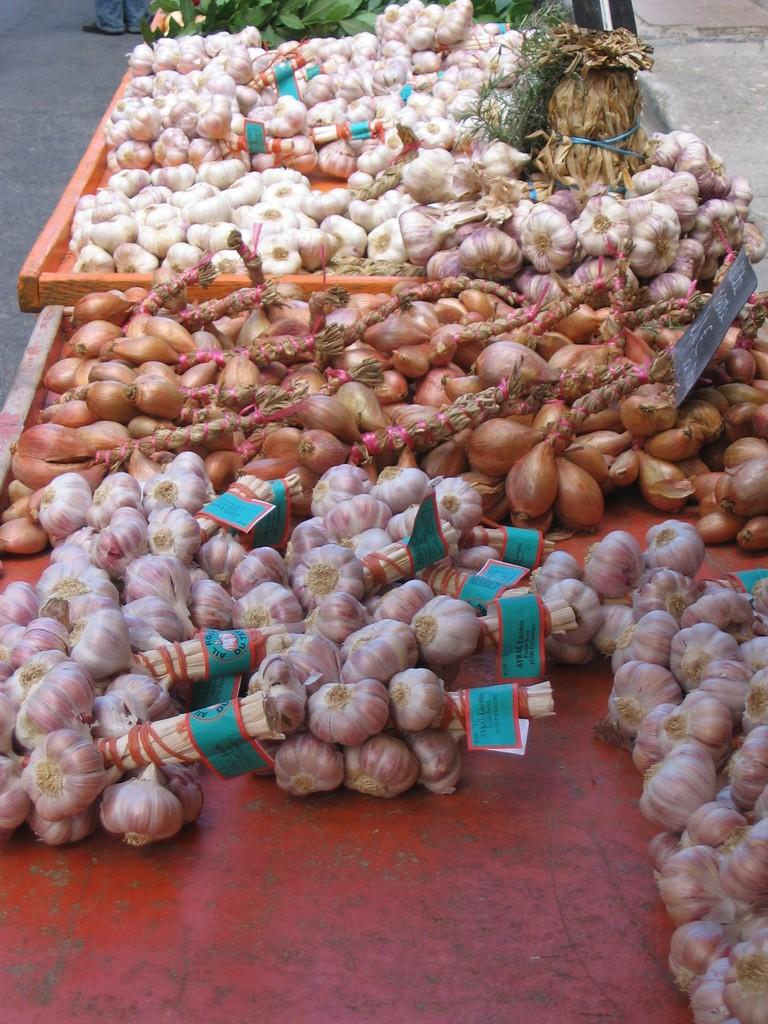What type of vegetables are present in the image? There are onions and garlic in the image. How are the onions and garlic stored in the image? The onions and garlic are kept in two carts. What can be found on the board in the onions cart? There is a board with text in the onions cart. How are the onions and garlic bundled together? The onions and garlic are tied as bunches. How can the bunches be identified? The bunches have labels. How many sisters are present in the image? There are no sisters present in the image; it features onions and garlic in carts. What is the texture of the skirt in the image? There is no skirt present in the image. 